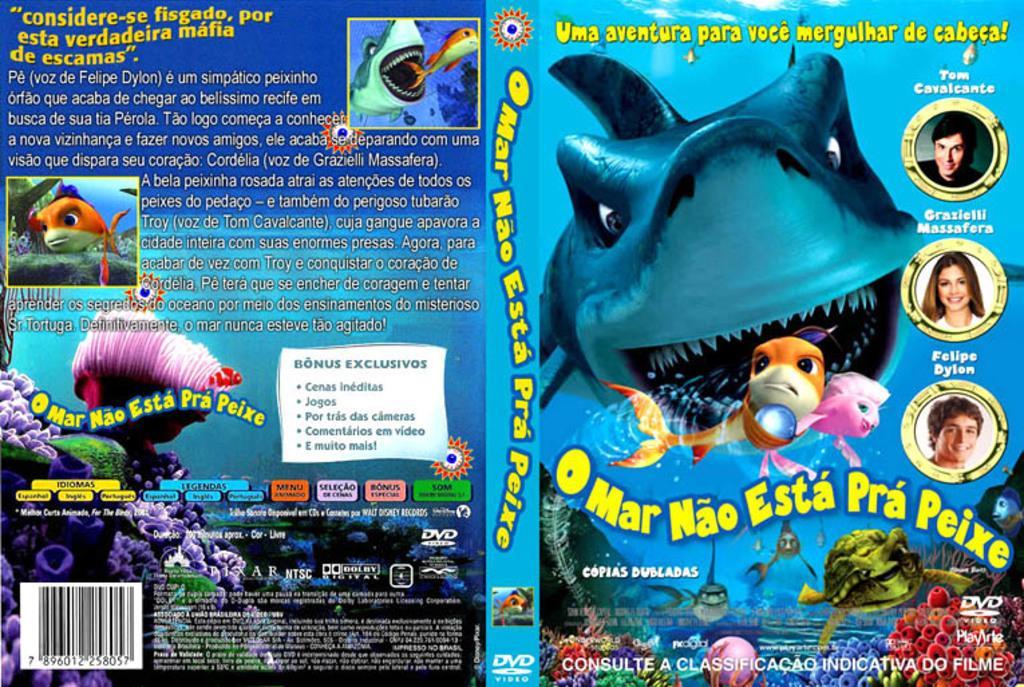How would you summarize this image in a sentence or two? In this image I can see a poster with some text written on it. 